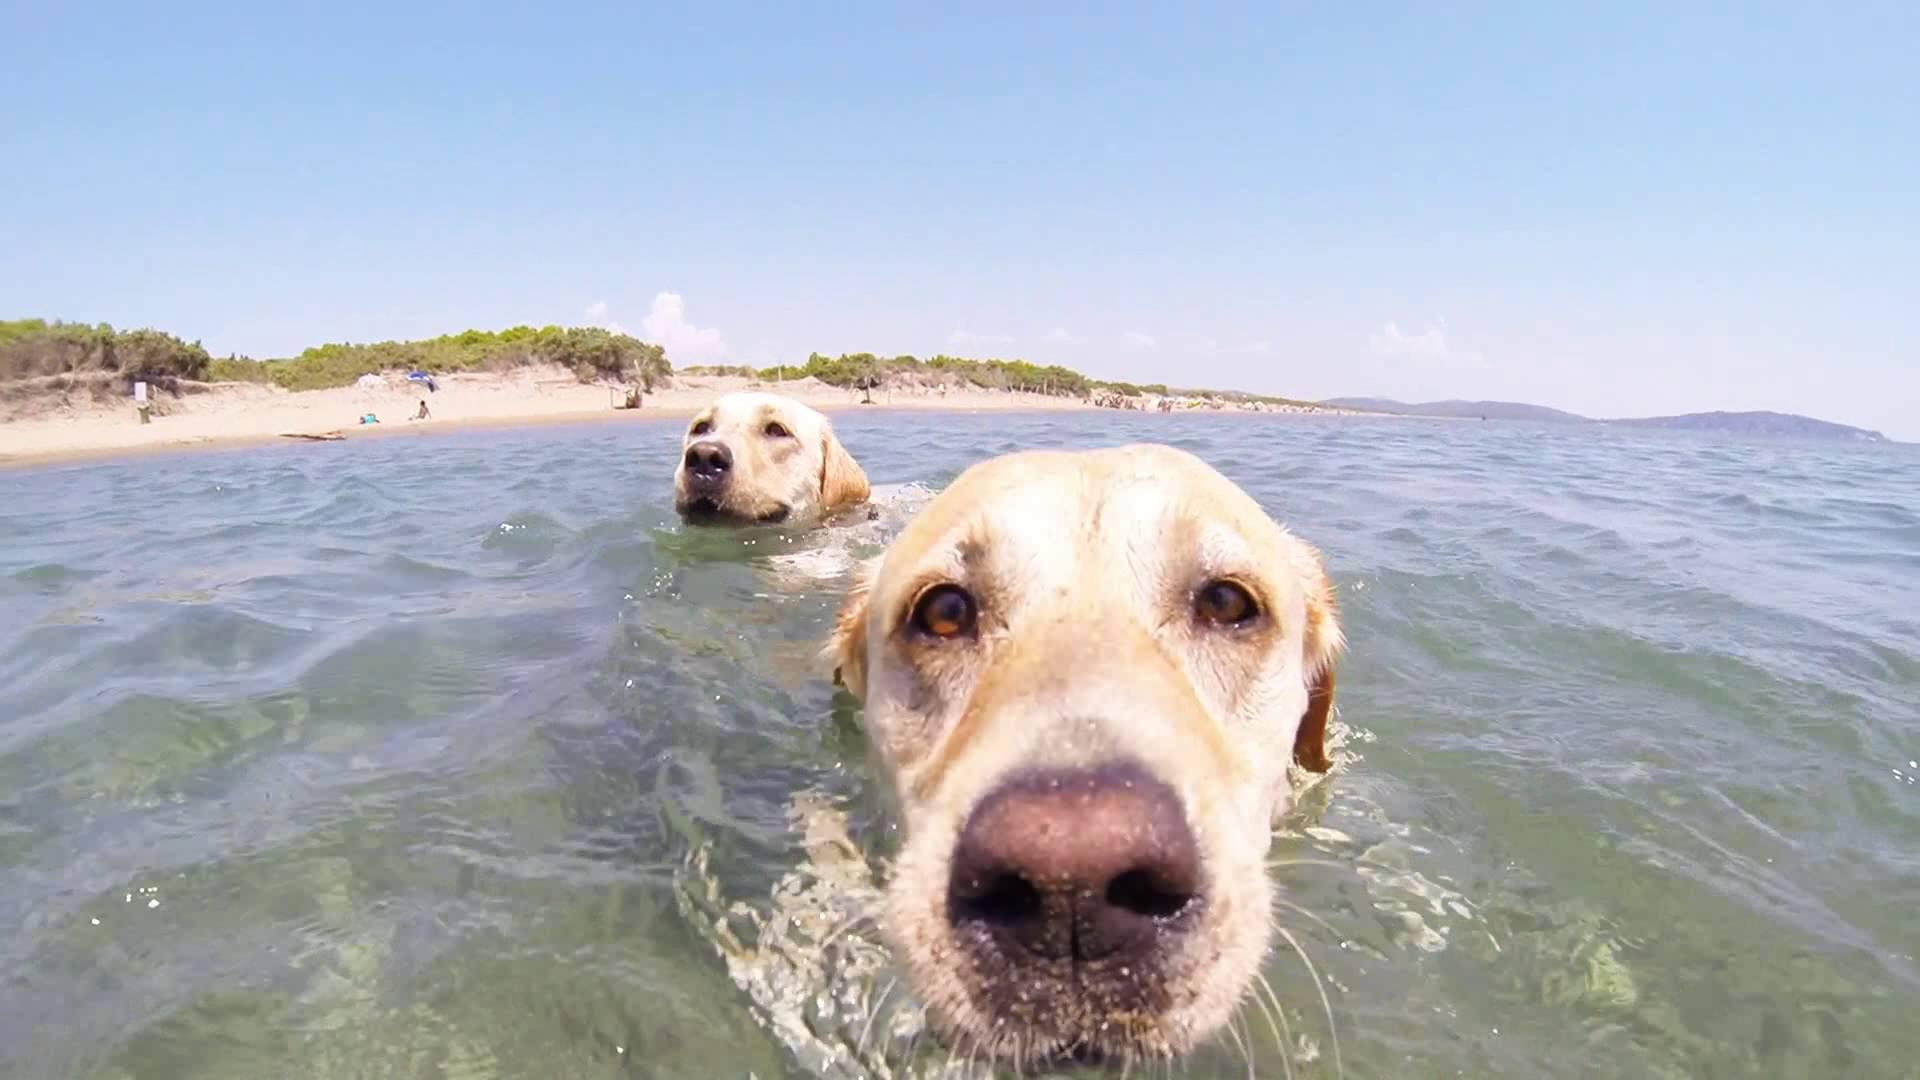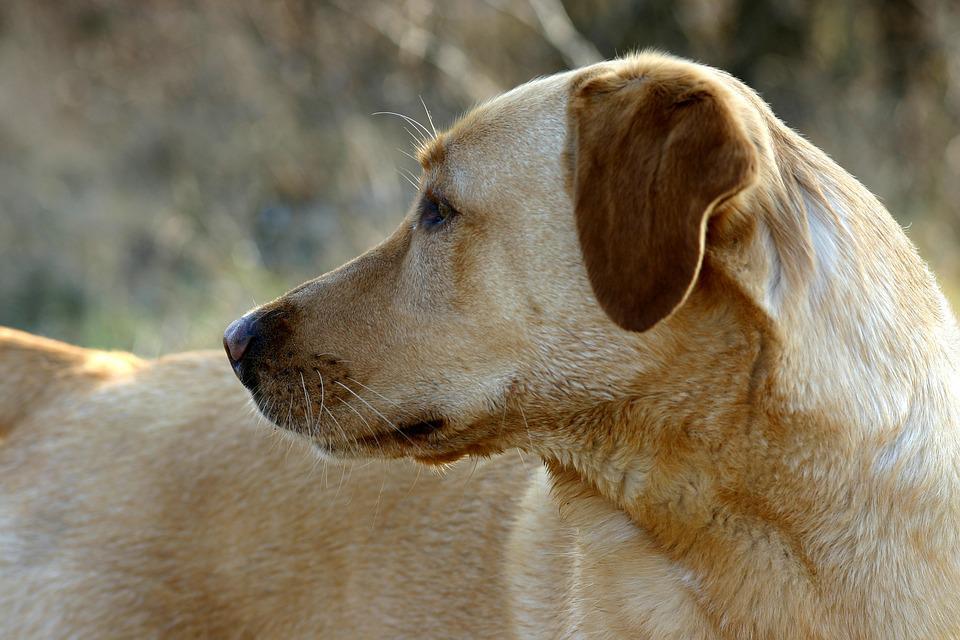The first image is the image on the left, the second image is the image on the right. For the images displayed, is the sentence "One dog has something in its mouth." factually correct? Answer yes or no. No. The first image is the image on the left, the second image is the image on the right. For the images shown, is this caption "a dog is swimming while carrying something in it's mouth" true? Answer yes or no. No. 